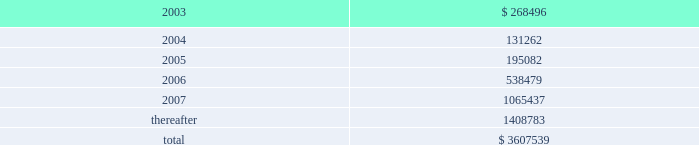American tower corporation and subsidiaries notes to consolidated financial statements 2014 ( continued ) 19 .
Subsequent events 12.25% ( 12.25 % ) senior subordinated discount notes and warrants offering 2014in january 2003 , the company issued 808000 units , each consisting of ( 1 ) $ 1000 principal amount at maturity of the 12.25% ( 12.25 % ) senior subordinated discount notes due 2008 of a wholly owned subsidiary of the company ( ati notes ) and ( 2 ) a warrant to purchase 14.0953 shares of class a common stock of the company , for gross proceeds of $ 420.0 million .
The gross offering proceeds were allocated between the ati notes ( $ 367.4 million ) and the fair value of the warrants ( $ 52.6 million ) .
Net proceeds from the offering aggregated approximately $ 397.0 million and were or will be used for the purposes described below under amended and restated loan agreement .
The ati notes accrue no cash interest .
Instead , the accreted value of each ati note will increase between the date of original issuance and maturity ( august 1 , 2008 ) at a rate of 12.25% ( 12.25 % ) per annum .
The 808000 warrants that were issued together with the ati notes each represent the right to purchase 14.0953 shares of class a common stock at $ 0.01 per share .
The warrants are exercisable at any time on or after january 29 , 2006 and will expire on august 1 , 2008 .
As of the issuance date , the warrants represented approximately 5.5% ( 5.5 % ) of the company 2019s outstanding common stock ( assuming exercise of all warrants ) .
The indenture governing the ati notes contains covenants that , among other things , limit the ability of the issuer subsidiary and its guarantors to incur or guarantee additional indebtedness , create liens , pay dividends or make other equity distributions , enter into agreements restricting the restricted subsidiaries 2019 ability to pay dividends , purchase or redeem capital stock , make investments and sell assets or consolidate or merge with or into other companies .
The ati notes rank junior in right of payment to all existing and future senior indebtedness , including all indebtedness outstanding under the credit facilities , and are structurally senior in right of payment to all existing and future indebtedness of the company .
Amended and restated loan agreement 2014on february 21 , 2003 , the company completed an amendment to its credit facilities .
The amendment provides for the following : 2022 prepayment of a portion of outstanding term loans .
The company agreed to prepay an aggregate of $ 200.0 million of the term loans outstanding under the credit facilities from a portion of the net proceeds of the ati notes offering completed in january 2003 .
This prepayment consisted of a $ 125.0 million prepayment of the term loan a and a $ 75.0 million prepayment of the term loan b , each to be applied to reduce future scheduled principal payments .
Giving effect to the prepayment of $ 200.0 million of term loans under the credit facility and the issuance of the ati notes as discussed above as well as the paydown of debt from net proceeds of the sale of mtn ( $ 24.5 million in february 2003 ) , the company 2019s aggregate principal payments of long- term debt , including capital leases , for the next five years and thereafter are as follows ( in thousands ) : year ending december 31 .

What was the percent of the company aggregate principal payments due in 2006? 
Computations: (538479 / 3607539)
Answer: 0.14926. 